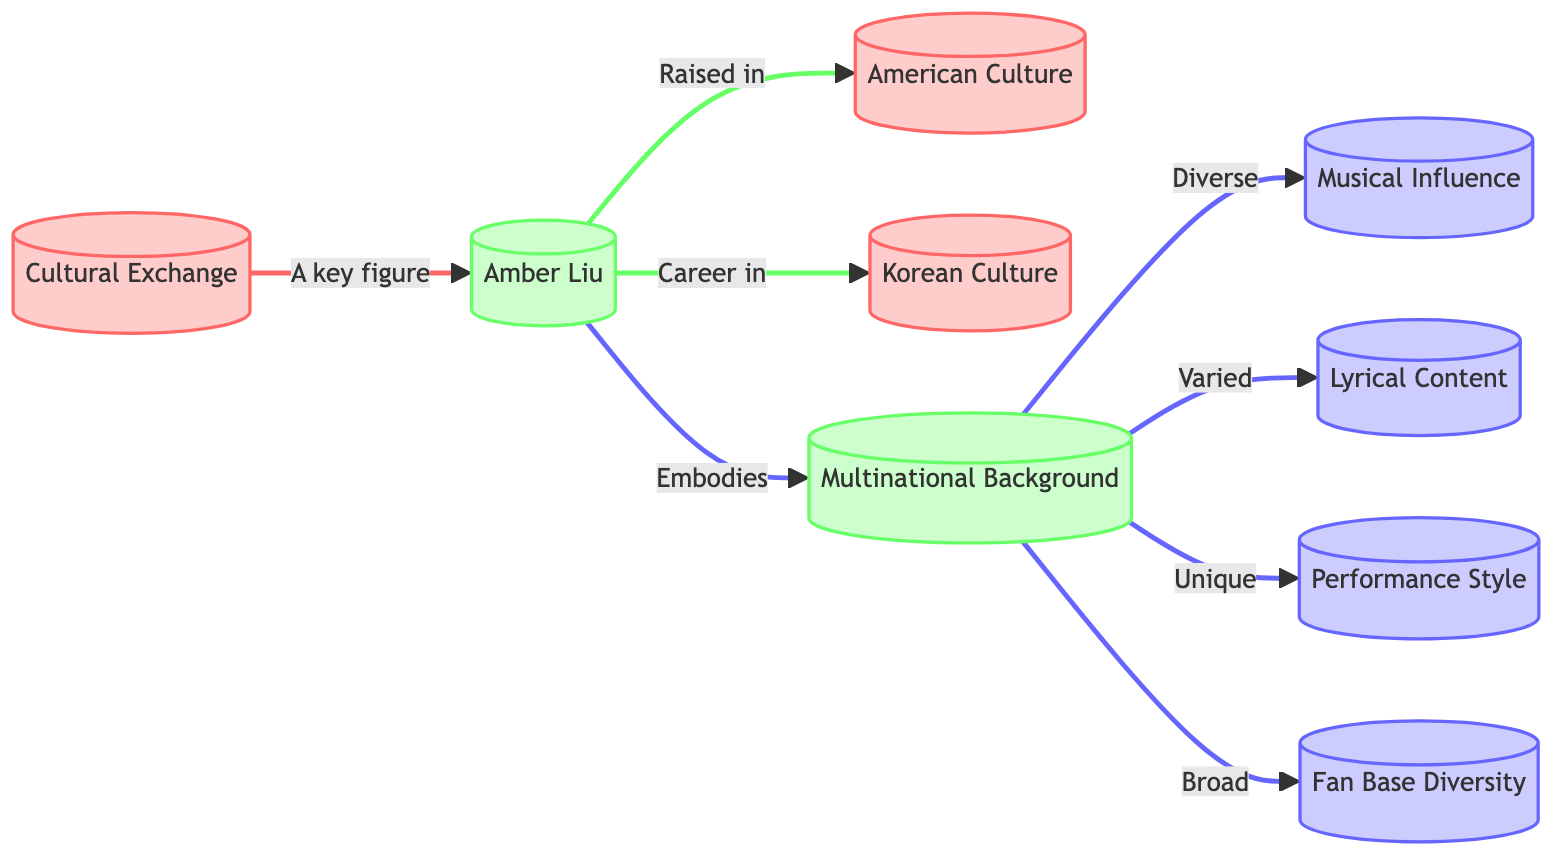What role does Amber Liu play in the cultural exchange? In the diagram, Amber Liu is identified as a "key figure" reflecting her significant role in the cultural exchange process. This indicates her contribution to bridging cultural gaps through her music and influence.
Answer: key figure Which cultures are represented in the diagram? The diagram distinctly mentions "American Culture" and "Korean Culture" as components of the cultural exchange related to Amber Liu, depicting the influence of these cultures on her identity and work.
Answer: American Culture, Korean Culture What influences emerge from Amber Liu's multinational background? The multinational background of Amber Liu leads to multiple influences: "musical influence", "lyrical content", "performance style", and "fan base diversity". Each of these areas showcases how her background enriches her artistry.
Answer: musical influence, lyrical content, performance style, fan base diversity How many types of influence are associated with her background? The diagram outlines four influences (musical influence, lyrical content, performance style, fan base diversity) stemming from Amber Liu's multinational background, highlighting the diversity of her artistic expression.
Answer: 4 What is the relationship between Amber Liu and her multinational background? According to the diagram, Amber Liu "embodies" a multinational background, showing how her diverse heritage is an integral part of her identity and artistic persona, shaping her work and public image.
Answer: embodies How does her multinational background influence her fan base? The diagram suggests that her multinational background leads to a "broad" fan base diversity, indicating a wide range of supporters from various cultural backgrounds, which enriches her audience engagement.
Answer: broad What is the unique aspect of Amber Liu's performance style? The diagram states that her multinational background contributes to a "unique" performance style, emphasizing that her diverse influences create a distinctive approach to her performances.
Answer: unique What concept connects cultural exchange and Amber Liu? The diagram highlights that cultural exchange directly connects to Amber Liu as she is labeled as a "key figure", establishing her as a central component in the discourse of cultural interactions in K-pop.
Answer: cultural exchange What does Amber Liu's career reflect in terms of culture? The diagram indicates that Amber Liu's career takes place within "Korean Culture", showcasing how her work utilizes and represents Korean cultural elements as part of her identity as an artist.
Answer: Korean Culture 